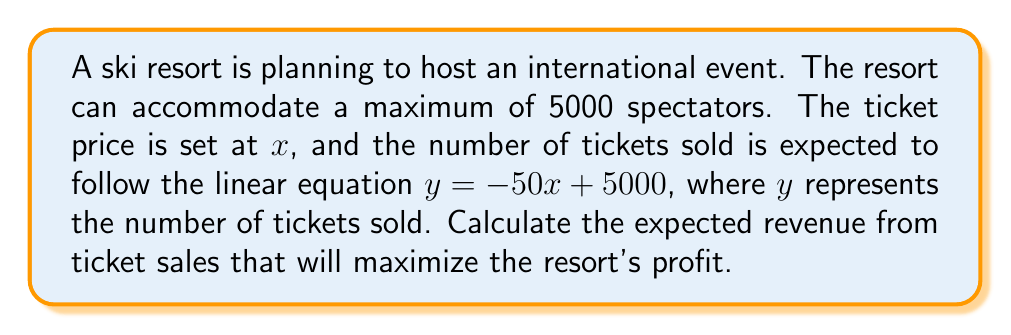Teach me how to tackle this problem. To solve this problem, we'll follow these steps:

1) The revenue function $R(x)$ is the product of the ticket price $x$ and the number of tickets sold $y$:

   $R(x) = xy = x(-50x + 5000)$

2) Expand the revenue function:

   $R(x) = -50x^2 + 5000x$

3) To find the maximum revenue, we need to find the vertex of this quadratic function. The x-coordinate of the vertex will give us the optimal ticket price.

4) For a quadratic function in the form $ax^2 + bx + c$, the x-coordinate of the vertex is given by $-\frac{b}{2a}$. Here, $a = -50$ and $b = 5000$.

5) Calculate the optimal ticket price:

   $x = -\frac{b}{2a} = -\frac{5000}{2(-50)} = \frac{5000}{100} = 50$

6) To find the maximum revenue, substitute $x = 50$ into the revenue function:

   $R(50) = -50(50)^2 + 5000(50)$
          $= -125000 + 250000$
          $= 125000$

Therefore, the maximum expected revenue is $125,000.
Answer: $125,000 